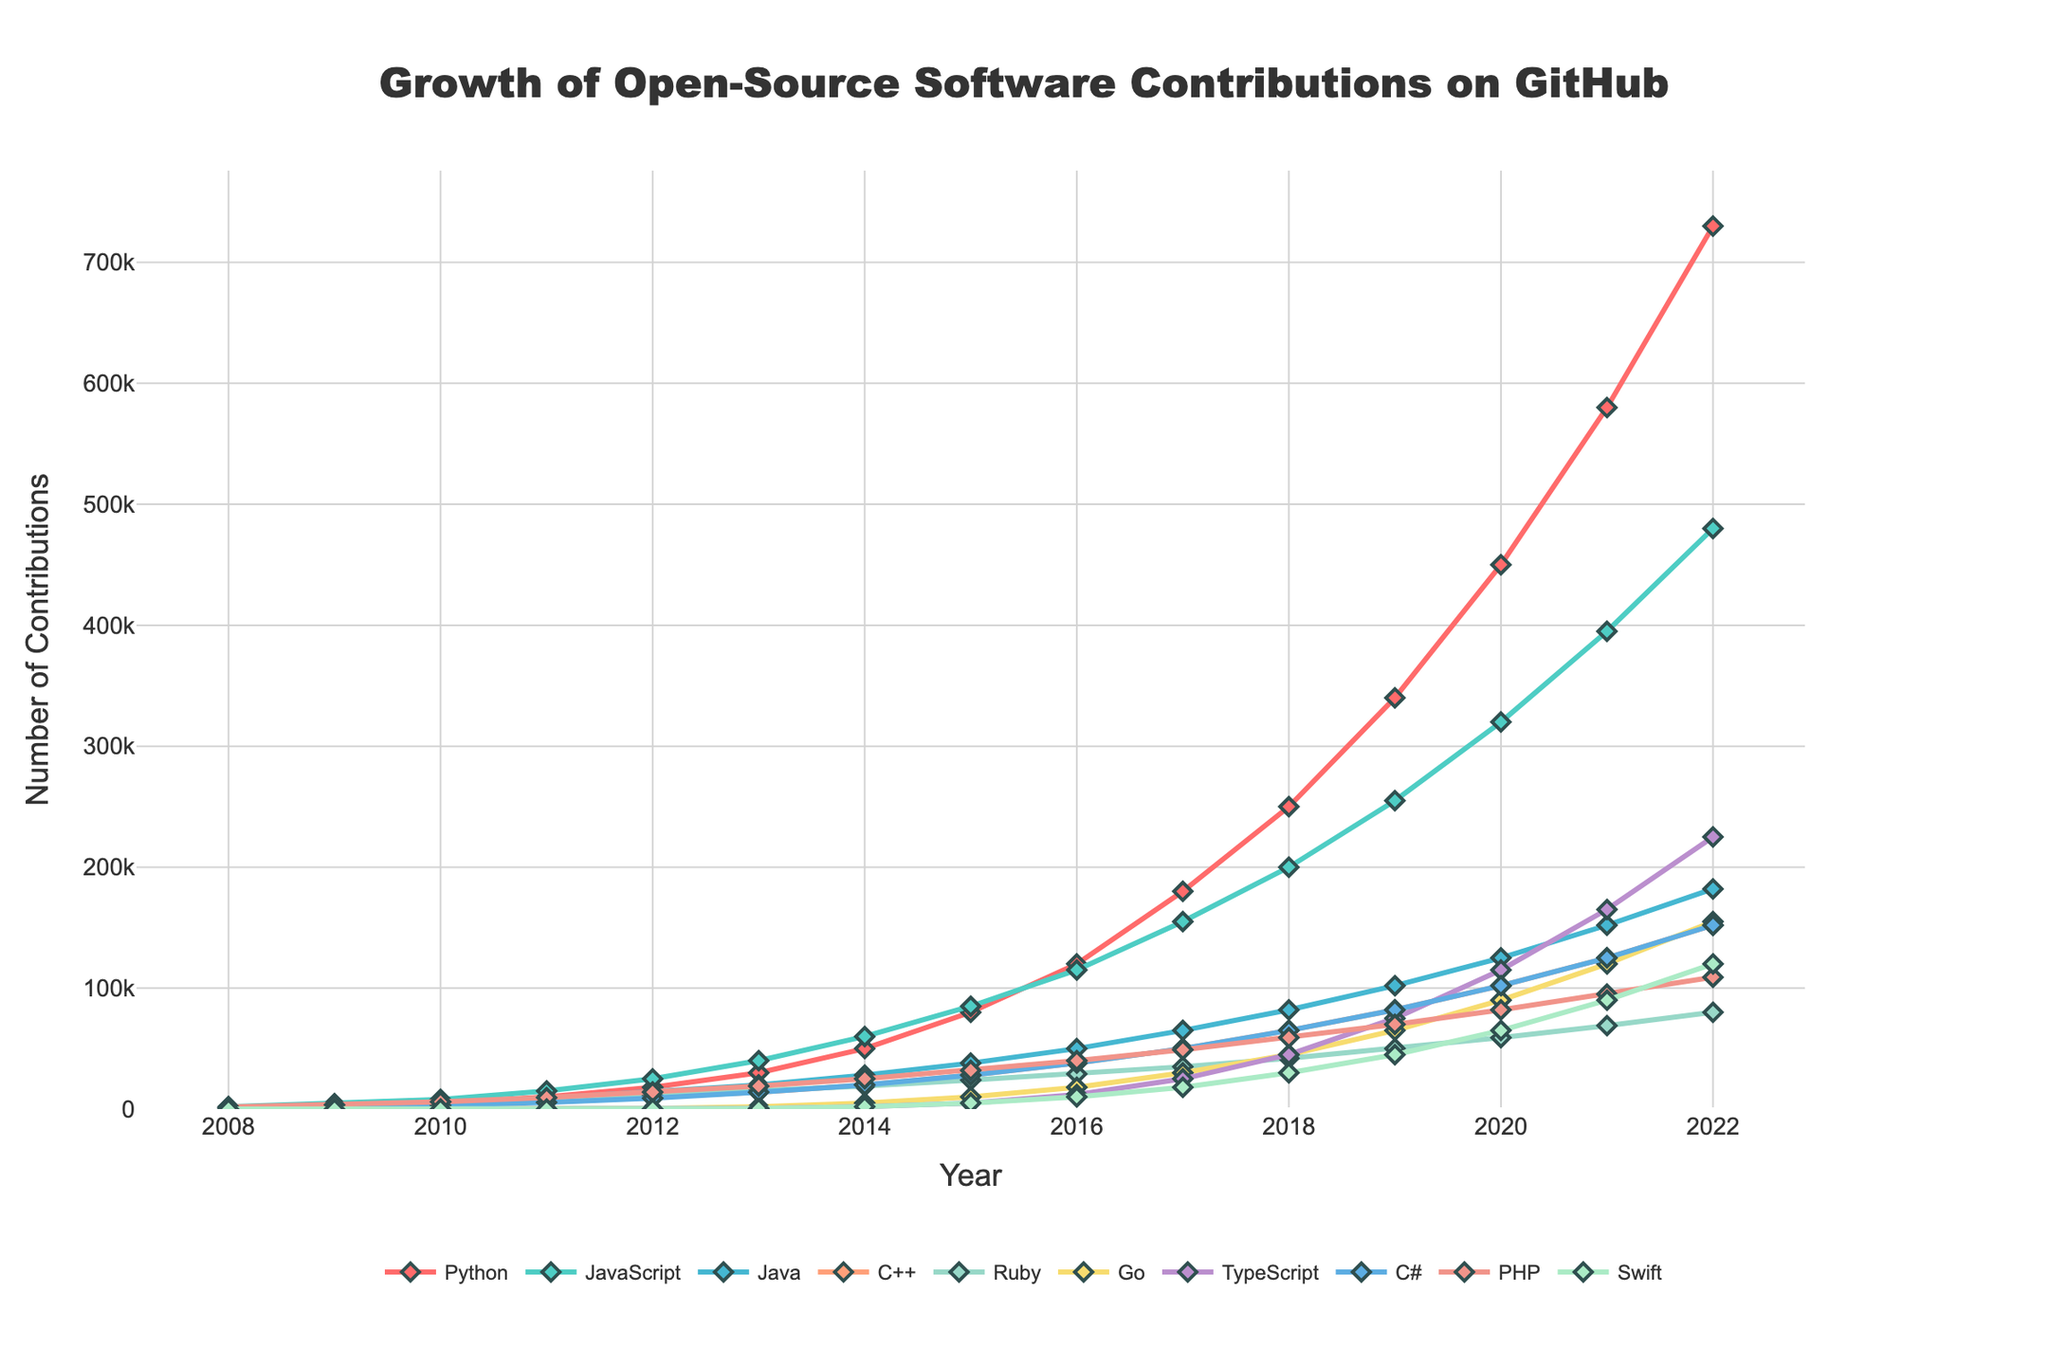What's the trend of Python contributions from 2008 to 2022? The contributions of Python show a clear upward trend from 2008 to 2022. In 2008, it started at 1,000 and consistently increased each year, reaching 730,000 in 2022.
Answer: Upward trend Which programming language had the highest number of contributions in 2022? By examining the highest points in 2022, the Python line visually stands out, indicating Python had the highest number of contributions at 730,000.
Answer: Python How do the contributions of JavaScript and TypeScript compare in 2020? Looking at the graph for the year 2020, the contributions for JavaScript were 320,000 while for TypeScript, it was 115,000. JavaScript contributions were higher.
Answer: JavaScript > TypeScript What's the average increase in contributions for Go from 2011 to 2014? Go had contributions of 100 in 2011 and 5000 in 2014. The difference over these years is 5000 - 100 = 4900. Dividing by the 3 years (2012, 2013, 2014) gives an average increase of 4900 / 3.
Answer: ~1633 per year Which language had the slowest growth in contributions from 2010 to 2013? By comparing the slopes of the lines, C# appears to have grown from 3000 in 2010 to 14000 in 2013, increasing by 11000. Ruby increased by only 6500 (4500 to 15000) in the same period, so Ruby had the slowest growth.
Answer: Ruby Estimate the percentage increase in Swift contributions from 2018 to 2019. Swift contributions were 30,000 in 2018 and 45,000 in 2019. The increase is 45,000 - 30,000 = 15,000. The percentage increase is (15,000/30,000) * 100 = 50%.
Answer: 50% Which year saw the largest jump in Java contributions and by how much? The graph shows the sharpest increase for Java between 2016 and 2017, where contributions jumped from 50,000 to 65,000, making the increase 65,000 - 50,000 = 15,000.
Answer: 2017, 15,000 How do the visual heights (contributions) of PHP and C++ compare in 2022? Observing the heights of the lines in 2022, PHP contributions are at 109,000 while C++ contributions are at 152,000. Visually, C++'s height is greater than PHP's.
Answer: C++ > PHP What is the ratio of Ruby to Swift contributions in 2020? For 2020, Ruby contributions are 59,000 and Swift contributions are 65,000. The ratio is 59,000:65,000, simplifying to approximately 59:65 or 0.91.
Answer: 0.91 Did contributions for any language plateau or decrease at any point between 2008 and 2022? Visually, all lines seem to exhibit consistent upward trends without plateauing or decreasing, indicating no clear plateaus or decreases in the data shown.
Answer: No 